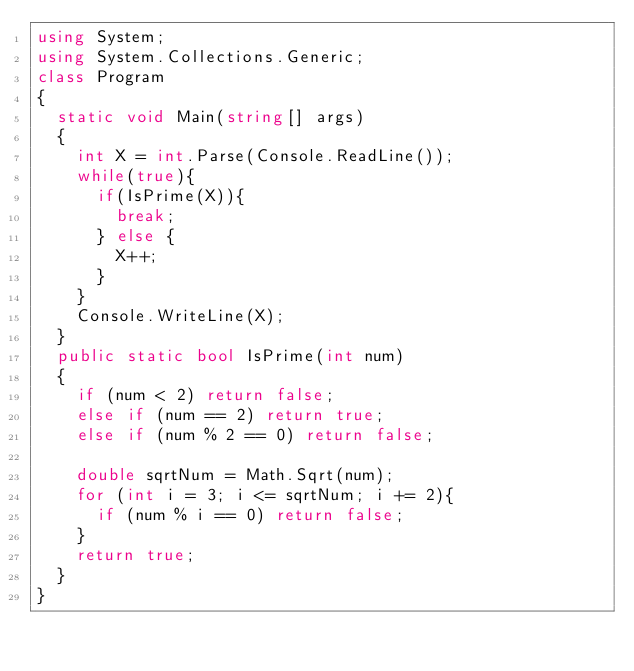<code> <loc_0><loc_0><loc_500><loc_500><_C#_>using System;
using System.Collections.Generic;
class Program
{
	static void Main(string[] args)
	{
		int X = int.Parse(Console.ReadLine());
		while(true){
			if(IsPrime(X)){
				break;
			} else {
				X++;
			}
		}
		Console.WriteLine(X);
	}
	public static bool IsPrime(int num)
	{
		if (num < 2) return false;
		else if (num == 2) return true;
		else if (num % 2 == 0) return false;

		double sqrtNum = Math.Sqrt(num);
		for (int i = 3; i <= sqrtNum; i += 2){
			if (num % i == 0) return false;
		}
		return true;
	}
}</code> 